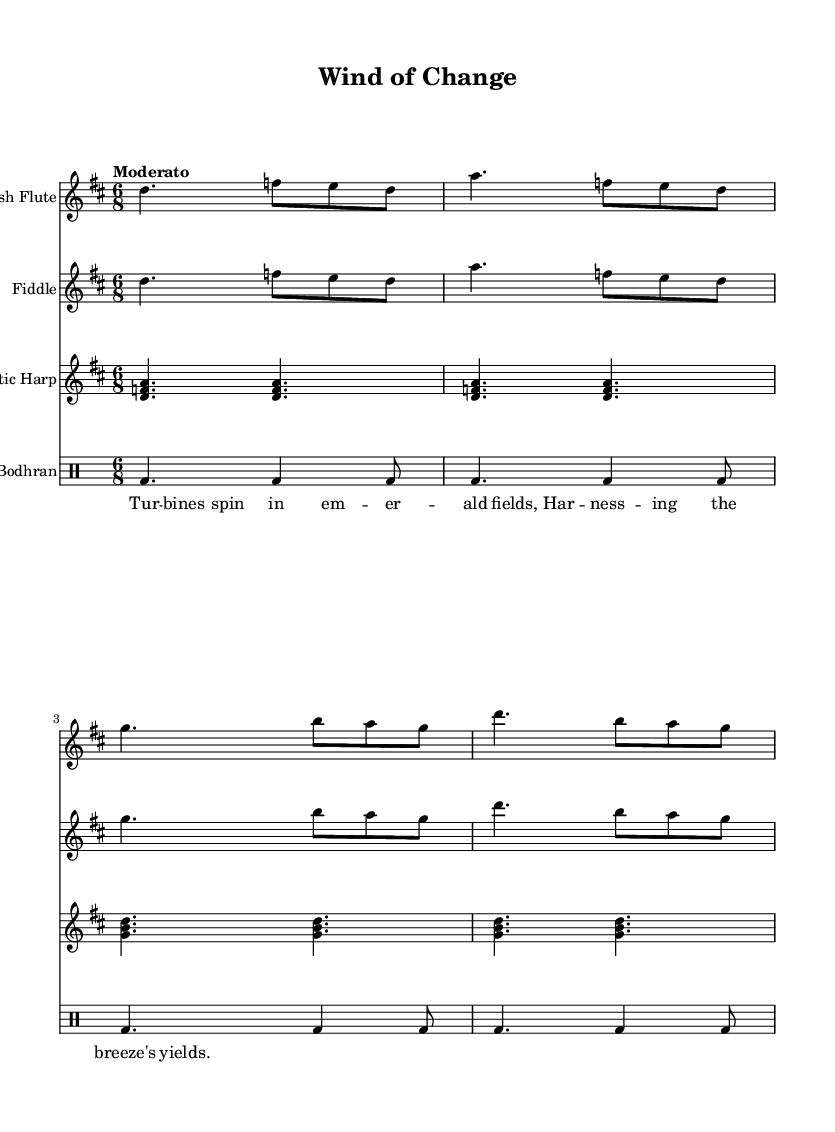What is the key signature of this music? The key signature is indicated by the number of sharps or flats at the beginning of the staff. In this case, it shows two sharps, which signifies D major.
Answer: D major What is the time signature of this music? The time signature is shown at the beginning of the music with two numbers stacked. Here, it indicates 6 over 8, meaning there are six eighth notes per measure.
Answer: 6/8 What is the tempo marking for this piece? The tempo marking is usually found above the staff. In this score, it states "Moderato," which suggests a moderate speed of play.
Answer: Moderato How many measures are present in the flute part? To find the number of measures, we count the vertical lines indicating the ends of measures in the music. The flute part has four distinct measures.
Answer: Four Which instruments are included in this score? The instruments are typically listed in the header or directly above the staves. This piece features the Irish flute, fiddle, Celtic harp, and bodhran.
Answer: Irish Flute, Fiddle, Celtic Harp, Bodhran What is the overall theme suggested by the lyrics of this piece? The lyrics imply a connection with natural elements, and it mentions turbines, which relates to renewable energy sources. This conveys a theme of harnessing nature for sustainable purposes.
Answer: Renewable energy 